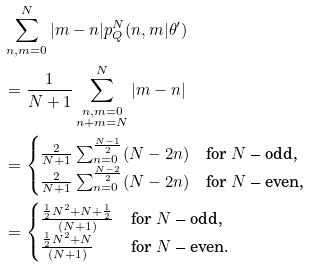<formula> <loc_0><loc_0><loc_500><loc_500>& \sum _ { n , m = 0 } ^ { N } | m - n | p _ { Q } ^ { N } ( n , m | \theta ^ { \prime } ) \\ & = \frac { 1 } { N + 1 } \sum _ { \substack { n , m = 0 \\ n + m = N } } ^ { N } | m - n | \\ & = \begin{cases} \frac { 2 } { N + 1 } \sum _ { n = 0 } ^ { \frac { N - 1 } { 2 } } ( N - 2 n ) & \text {for $N$ -- odd,} \\ \frac { 2 } { N + 1 } \sum _ { n = 0 } ^ { \frac { N - 2 } { 2 } } ( N - 2 n ) & \text {for $N$ -- even,} \end{cases} \\ & = \begin{cases} \frac { \frac { 1 } { 2 } N ^ { 2 } + N + \frac { 1 } { 2 } } { ( N + 1 ) } & \text {for $N$ -- odd,} \\ \frac { \frac { 1 } { 2 } N ^ { 2 } + N } { ( N + 1 ) } & \text {for $N$ -- even.} \end{cases}</formula> 